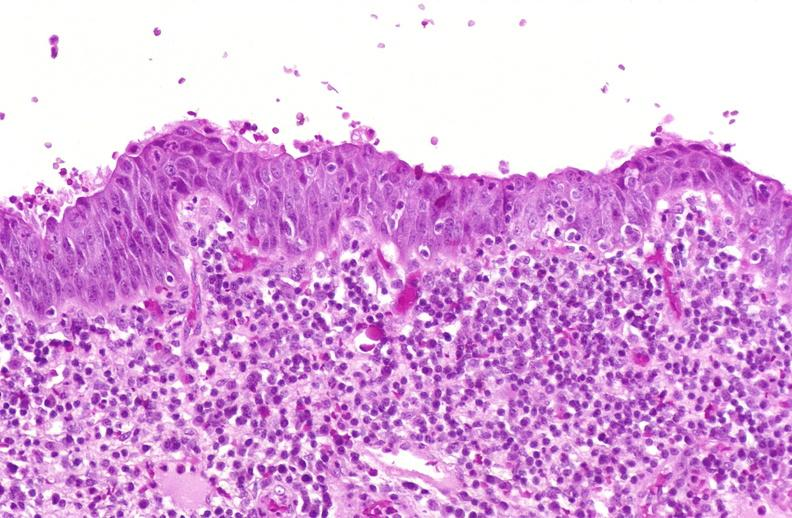what is present?
Answer the question using a single word or phrase. Urinary 